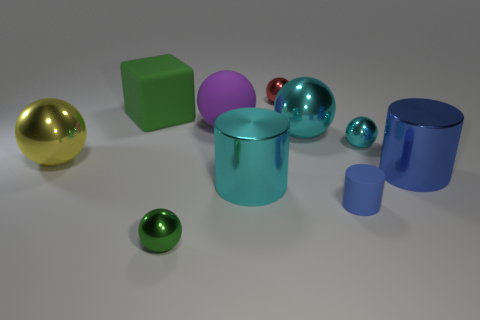Subtract all green cubes. How many blue cylinders are left? 2 Subtract 1 cylinders. How many cylinders are left? 2 Subtract all rubber balls. How many balls are left? 5 Subtract all green spheres. How many spheres are left? 5 Subtract all blue spheres. Subtract all gray cubes. How many spheres are left? 6 Subtract all cylinders. How many objects are left? 7 Add 8 tiny green balls. How many tiny green balls exist? 9 Subtract 0 brown spheres. How many objects are left? 10 Subtract all shiny cylinders. Subtract all tiny purple metal cubes. How many objects are left? 8 Add 4 small cyan metal spheres. How many small cyan metal spheres are left? 5 